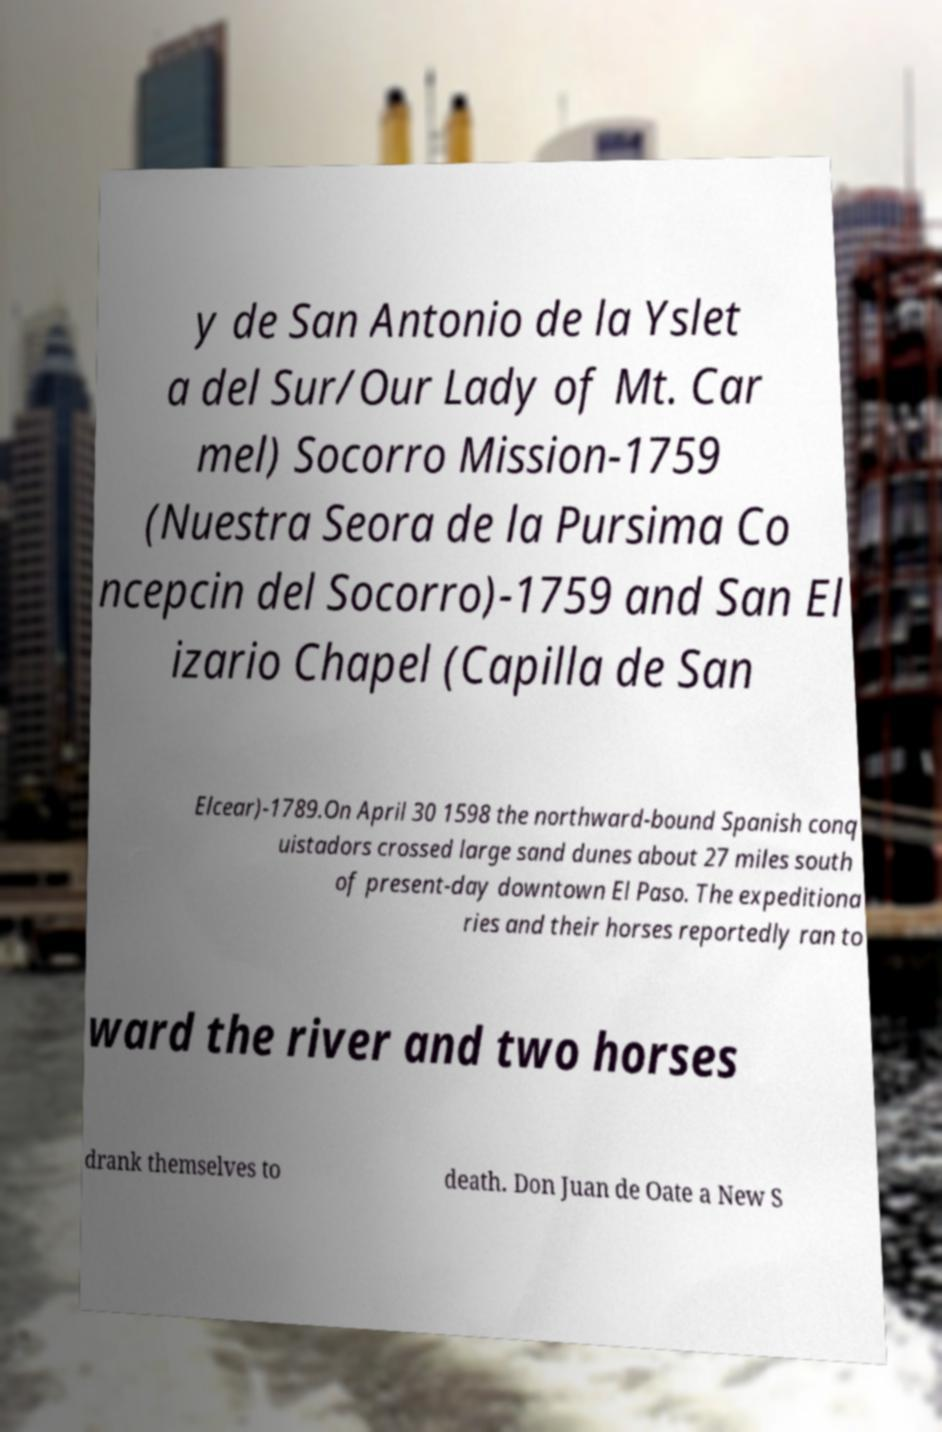I need the written content from this picture converted into text. Can you do that? y de San Antonio de la Yslet a del Sur/Our Lady of Mt. Car mel) Socorro Mission-1759 (Nuestra Seora de la Pursima Co ncepcin del Socorro)-1759 and San El izario Chapel (Capilla de San Elcear)-1789.On April 30 1598 the northward-bound Spanish conq uistadors crossed large sand dunes about 27 miles south of present-day downtown El Paso. The expeditiona ries and their horses reportedly ran to ward the river and two horses drank themselves to death. Don Juan de Oate a New S 